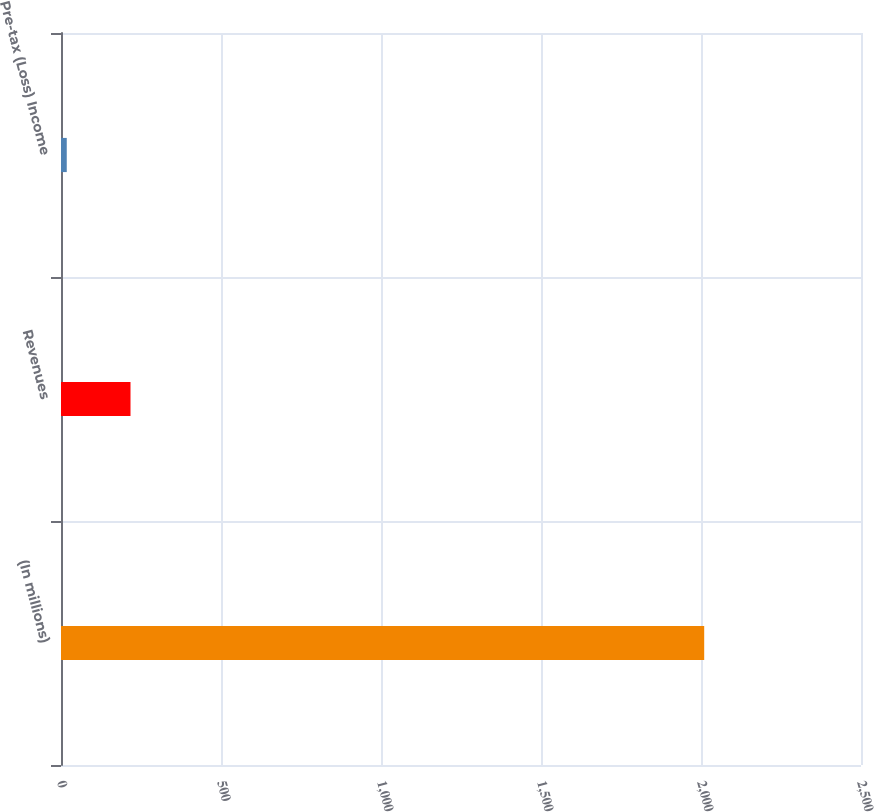Convert chart to OTSL. <chart><loc_0><loc_0><loc_500><loc_500><bar_chart><fcel>(In millions)<fcel>Revenues<fcel>Pre-tax (Loss) Income<nl><fcel>2010<fcel>217.2<fcel>18<nl></chart> 